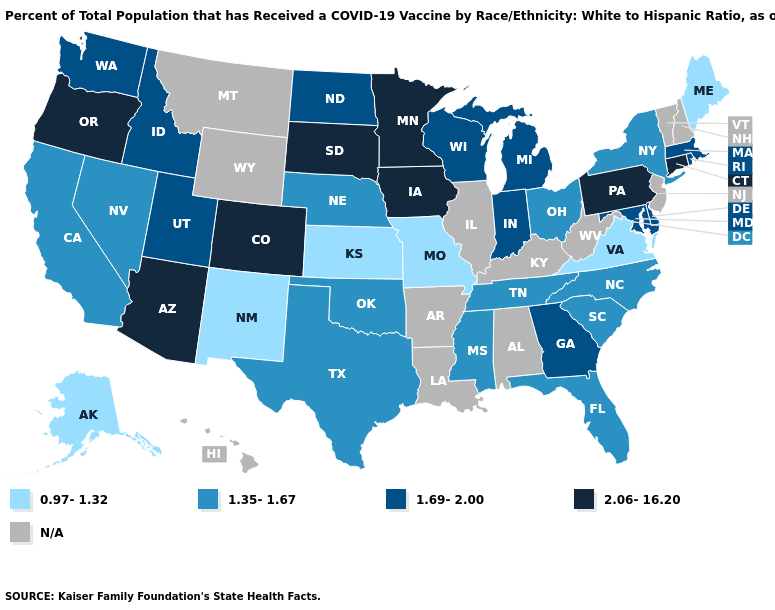What is the highest value in states that border Nebraska?
Concise answer only. 2.06-16.20. What is the highest value in the USA?
Give a very brief answer. 2.06-16.20. Does Massachusetts have the lowest value in the USA?
Quick response, please. No. Does Kansas have the lowest value in the MidWest?
Give a very brief answer. Yes. Which states have the highest value in the USA?
Quick response, please. Arizona, Colorado, Connecticut, Iowa, Minnesota, Oregon, Pennsylvania, South Dakota. Which states have the highest value in the USA?
Short answer required. Arizona, Colorado, Connecticut, Iowa, Minnesota, Oregon, Pennsylvania, South Dakota. Does Arizona have the highest value in the USA?
Keep it brief. Yes. Does Missouri have the lowest value in the MidWest?
Be succinct. Yes. What is the value of Colorado?
Write a very short answer. 2.06-16.20. What is the lowest value in states that border Alabama?
Write a very short answer. 1.35-1.67. Does South Dakota have the highest value in the USA?
Concise answer only. Yes. Name the states that have a value in the range N/A?
Write a very short answer. Alabama, Arkansas, Hawaii, Illinois, Kentucky, Louisiana, Montana, New Hampshire, New Jersey, Vermont, West Virginia, Wyoming. Does the map have missing data?
Write a very short answer. Yes. Which states have the lowest value in the USA?
Write a very short answer. Alaska, Kansas, Maine, Missouri, New Mexico, Virginia. Does Pennsylvania have the highest value in the Northeast?
Quick response, please. Yes. 